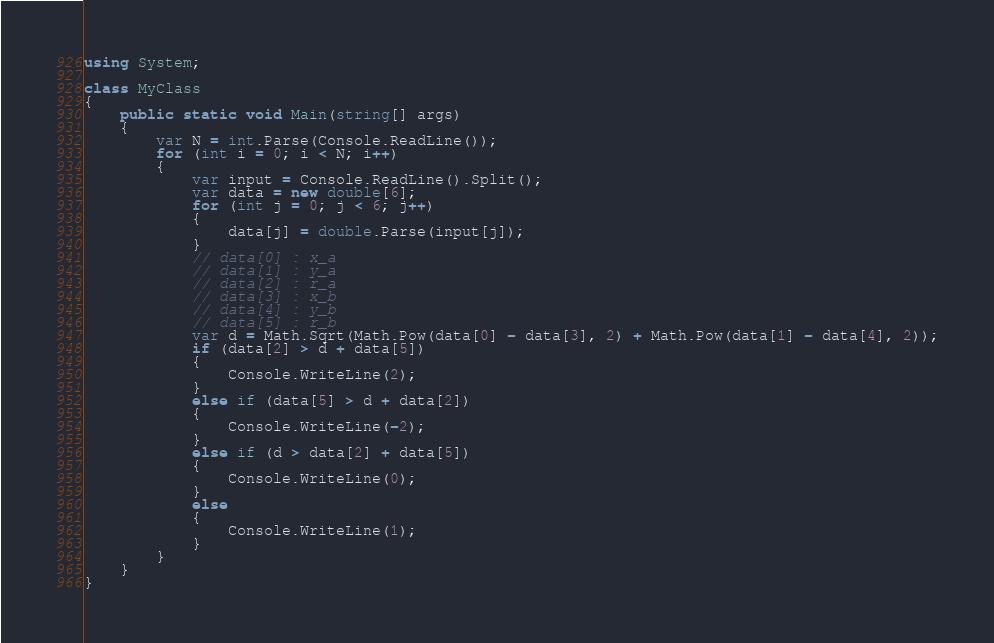<code> <loc_0><loc_0><loc_500><loc_500><_C#_>using System;

class MyClass
{
    public static void Main(string[] args)
    {
        var N = int.Parse(Console.ReadLine());
        for (int i = 0; i < N; i++)
        {
            var input = Console.ReadLine().Split();
            var data = new double[6];
            for (int j = 0; j < 6; j++)
            {
                data[j] = double.Parse(input[j]);
            }
            // data[0] : x_a
            // data[1] : y_a
            // data[2] : r_a
            // data[3] : x_b
            // data[4] : y_b
            // data[5] : r_b
            var d = Math.Sqrt(Math.Pow(data[0] - data[3], 2) + Math.Pow(data[1] - data[4], 2));
            if (data[2] > d + data[5])
            {
                Console.WriteLine(2);
            }
            else if (data[5] > d + data[2])
            {
                Console.WriteLine(-2);
            }
            else if (d > data[2] + data[5])
            {
                Console.WriteLine(0);
            }
            else
            {
                Console.WriteLine(1);
            }
        }
    }
}
</code> 